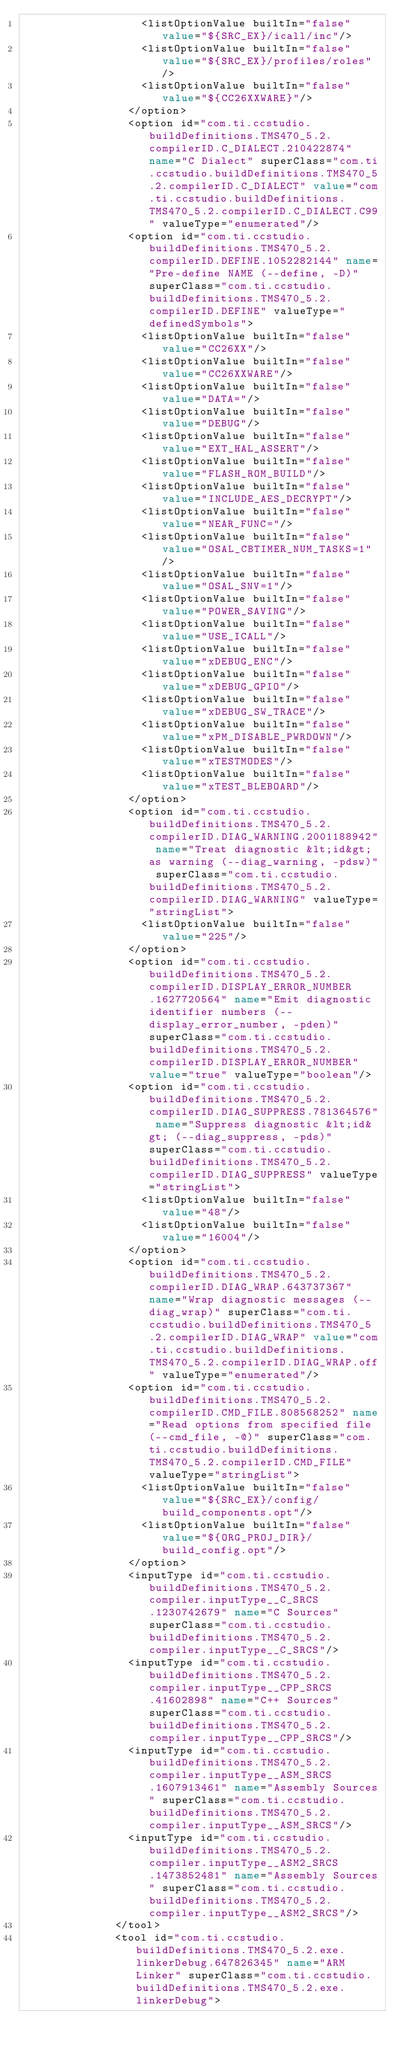<code> <loc_0><loc_0><loc_500><loc_500><_XML_>                  <listOptionValue builtIn="false" value="${SRC_EX}/icall/inc"/>
                  <listOptionValue builtIn="false" value="${SRC_EX}/profiles/roles"/>
                  <listOptionValue builtIn="false" value="${CC26XXWARE}"/>
                </option>
                <option id="com.ti.ccstudio.buildDefinitions.TMS470_5.2.compilerID.C_DIALECT.210422874" name="C Dialect" superClass="com.ti.ccstudio.buildDefinitions.TMS470_5.2.compilerID.C_DIALECT" value="com.ti.ccstudio.buildDefinitions.TMS470_5.2.compilerID.C_DIALECT.C99" valueType="enumerated"/>
                <option id="com.ti.ccstudio.buildDefinitions.TMS470_5.2.compilerID.DEFINE.1052282144" name="Pre-define NAME (--define, -D)" superClass="com.ti.ccstudio.buildDefinitions.TMS470_5.2.compilerID.DEFINE" valueType="definedSymbols">
                  <listOptionValue builtIn="false" value="CC26XX"/>
                  <listOptionValue builtIn="false" value="CC26XXWARE"/>
                  <listOptionValue builtIn="false" value="DATA="/>
                  <listOptionValue builtIn="false" value="DEBUG"/>
                  <listOptionValue builtIn="false" value="EXT_HAL_ASSERT"/>
                  <listOptionValue builtIn="false" value="FLASH_ROM_BUILD"/>
                  <listOptionValue builtIn="false" value="INCLUDE_AES_DECRYPT"/>
                  <listOptionValue builtIn="false" value="NEAR_FUNC="/>
                  <listOptionValue builtIn="false" value="OSAL_CBTIMER_NUM_TASKS=1"/>
                  <listOptionValue builtIn="false" value="OSAL_SNV=1"/>
                  <listOptionValue builtIn="false" value="POWER_SAVING"/>
                  <listOptionValue builtIn="false" value="USE_ICALL"/>
                  <listOptionValue builtIn="false" value="xDEBUG_ENC"/>
                  <listOptionValue builtIn="false" value="xDEBUG_GPIO"/>
                  <listOptionValue builtIn="false" value="xDEBUG_SW_TRACE"/>
                  <listOptionValue builtIn="false" value="xPM_DISABLE_PWRDOWN"/>
                  <listOptionValue builtIn="false" value="xTESTMODES"/>
                  <listOptionValue builtIn="false" value="xTEST_BLEBOARD"/>
                </option>
                <option id="com.ti.ccstudio.buildDefinitions.TMS470_5.2.compilerID.DIAG_WARNING.2001188942" name="Treat diagnostic &lt;id&gt; as warning (--diag_warning, -pdsw)" superClass="com.ti.ccstudio.buildDefinitions.TMS470_5.2.compilerID.DIAG_WARNING" valueType="stringList">
                  <listOptionValue builtIn="false" value="225"/>
                </option>
                <option id="com.ti.ccstudio.buildDefinitions.TMS470_5.2.compilerID.DISPLAY_ERROR_NUMBER.1627720564" name="Emit diagnostic identifier numbers (--display_error_number, -pden)" superClass="com.ti.ccstudio.buildDefinitions.TMS470_5.2.compilerID.DISPLAY_ERROR_NUMBER" value="true" valueType="boolean"/>
                <option id="com.ti.ccstudio.buildDefinitions.TMS470_5.2.compilerID.DIAG_SUPPRESS.781364576" name="Suppress diagnostic &lt;id&gt; (--diag_suppress, -pds)" superClass="com.ti.ccstudio.buildDefinitions.TMS470_5.2.compilerID.DIAG_SUPPRESS" valueType="stringList">
                  <listOptionValue builtIn="false" value="48"/>
                  <listOptionValue builtIn="false" value="16004"/>
                </option>
                <option id="com.ti.ccstudio.buildDefinitions.TMS470_5.2.compilerID.DIAG_WRAP.643737367" name="Wrap diagnostic messages (--diag_wrap)" superClass="com.ti.ccstudio.buildDefinitions.TMS470_5.2.compilerID.DIAG_WRAP" value="com.ti.ccstudio.buildDefinitions.TMS470_5.2.compilerID.DIAG_WRAP.off" valueType="enumerated"/>
                <option id="com.ti.ccstudio.buildDefinitions.TMS470_5.2.compilerID.CMD_FILE.808568252" name="Read options from specified file (--cmd_file, -@)" superClass="com.ti.ccstudio.buildDefinitions.TMS470_5.2.compilerID.CMD_FILE" valueType="stringList">
                  <listOptionValue builtIn="false" value="${SRC_EX}/config/build_components.opt"/>
                  <listOptionValue builtIn="false" value="${ORG_PROJ_DIR}/build_config.opt"/>
                </option>
                <inputType id="com.ti.ccstudio.buildDefinitions.TMS470_5.2.compiler.inputType__C_SRCS.1230742679" name="C Sources" superClass="com.ti.ccstudio.buildDefinitions.TMS470_5.2.compiler.inputType__C_SRCS"/>
                <inputType id="com.ti.ccstudio.buildDefinitions.TMS470_5.2.compiler.inputType__CPP_SRCS.41602898" name="C++ Sources" superClass="com.ti.ccstudio.buildDefinitions.TMS470_5.2.compiler.inputType__CPP_SRCS"/>
                <inputType id="com.ti.ccstudio.buildDefinitions.TMS470_5.2.compiler.inputType__ASM_SRCS.1607913461" name="Assembly Sources" superClass="com.ti.ccstudio.buildDefinitions.TMS470_5.2.compiler.inputType__ASM_SRCS"/>
                <inputType id="com.ti.ccstudio.buildDefinitions.TMS470_5.2.compiler.inputType__ASM2_SRCS.1473852481" name="Assembly Sources" superClass="com.ti.ccstudio.buildDefinitions.TMS470_5.2.compiler.inputType__ASM2_SRCS"/>
              </tool>
              <tool id="com.ti.ccstudio.buildDefinitions.TMS470_5.2.exe.linkerDebug.647826345" name="ARM Linker" superClass="com.ti.ccstudio.buildDefinitions.TMS470_5.2.exe.linkerDebug"></code> 